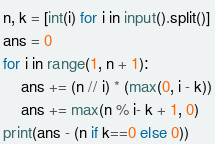<code> <loc_0><loc_0><loc_500><loc_500><_Python_>n, k = [int(i) for i in input().split()]
ans = 0
for i in range(1, n + 1):
    ans += (n // i) * (max(0, i - k))
    ans += max(n % i- k + 1, 0)
print(ans - (n if k==0 else 0))
</code> 